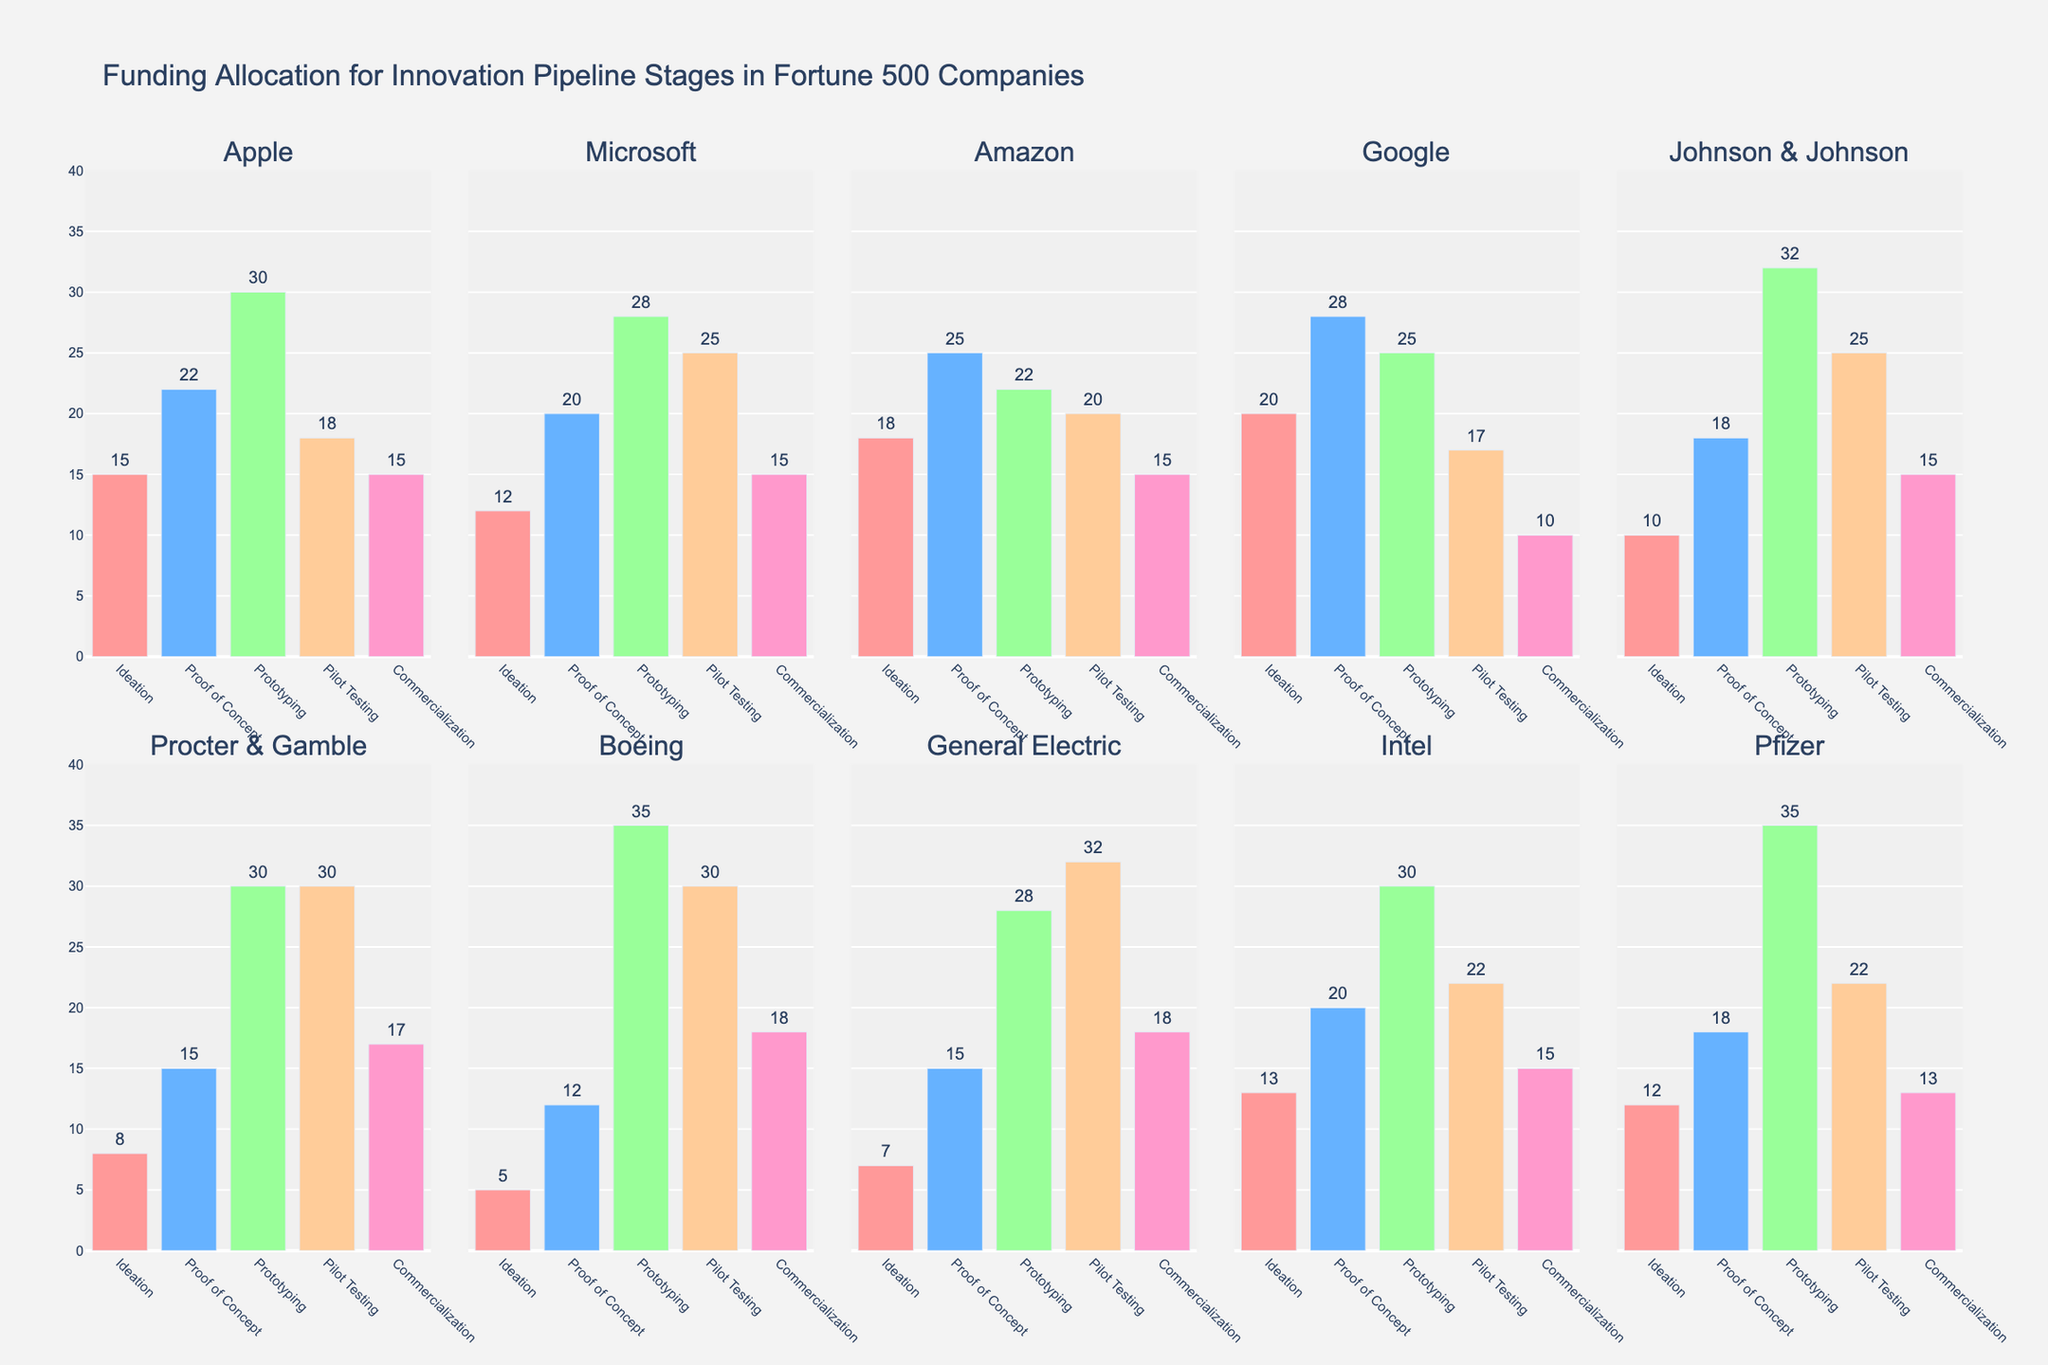What is the title of the figure? The title is usually located at the top of the figure and provides a summary of what the data represents. In this case, it is "Distribution of Funding Allocations for Marketing Research Materials".
Answer: Distribution of Funding Allocations for Marketing Research Materials How many subplots are in the figure? By observing the grid layout of the figure, there are 2 rows and 3 columns of subplots, leading to a total count.
Answer: 6 Which category has the highest average funding allocation across all libraries? To find the average funding for each category, sum all the values and divide by the number of libraries, then compare them. Books: 286/10, Journals: 350/10, Databases: 219/10, Software: 96/10, Conferences: 51/10. Journals have the highest average.
Answer: Journals Which library allocates the most funding for databases? Look at the 'Databases' subplot and find the highest bar. MIT has the highest value at 25 for databases.
Answer: MIT What is the total funding for software and conferences for University of Oxford? For University of Oxford, the funding is 9 for software and 6 for conferences. Summing these values gives the total.
Answer: 15 Are there any libraries with equal funding for the Books and Conferences categories? Check each library's funding for Books and Conferences to see if any values match. Yale University and Columbia University both allocate 6 to Conferences while the Books category funding is different. Thus, none have equal funding.
Answer: No Which category does University of Chicago allocate the least funding to? Find the bar with the shortest height for University of Chicago. In this case, it is the Software category at 8.
Answer: Software What is the total funding allocation for Yale University across all categories? Sum the values of all categories for Yale University. Books: 29, Journals: 36, Databases: 19, Software: 10, Conferences: 6. Summing these gives 29+36+19+10+6 = 100.
Answer: 100 Is Stanford University’s funding for Conferences higher than MIT? Compare the heights of the Conference bars for Stanford University and MIT. Both allocate 3.
Answer: No Which libraries allocate more funding to books than to journals? Compare the Books and Journals bars for each library to see if the Books bar is taller. University of Oxford (Books: 32, Journals: 30) and University of Cambridge (Books: 31, Journals: 33) have higher funding for books than journals.
Answer: University of Oxford, University of Cambridge 